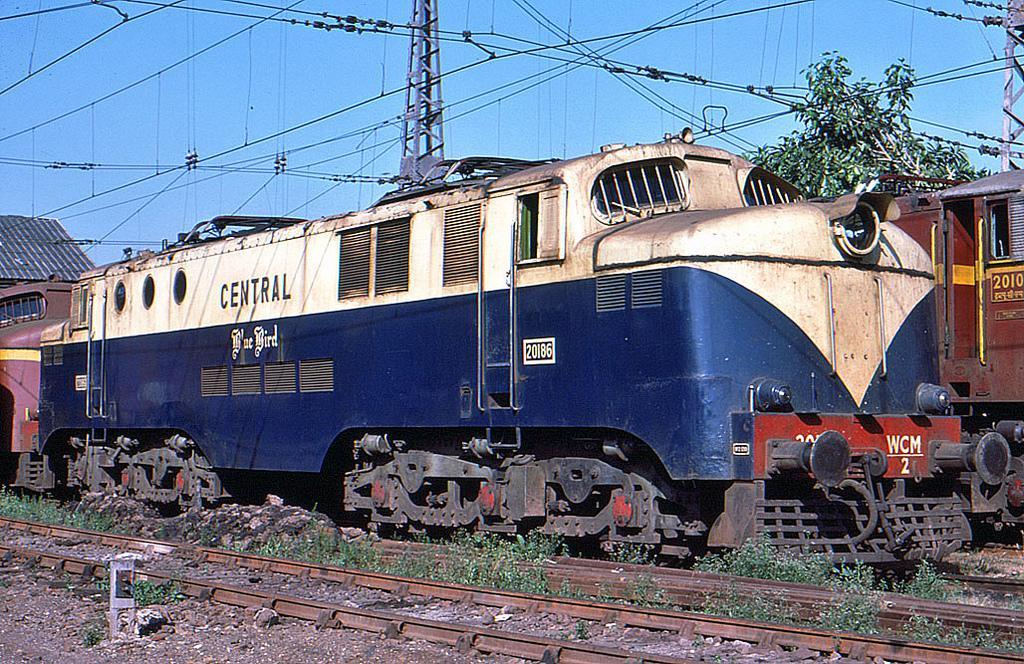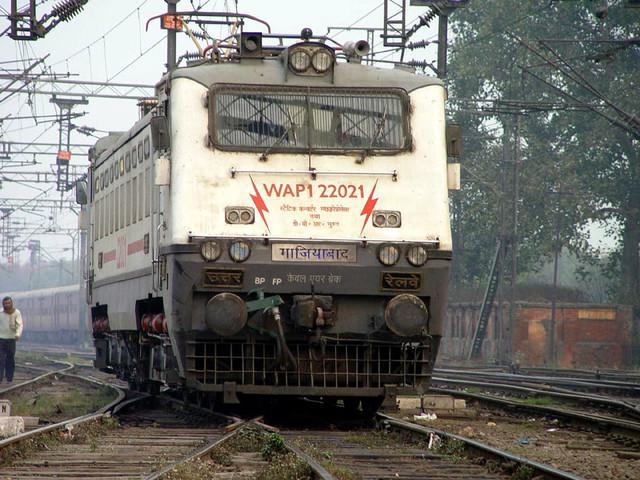The first image is the image on the left, the second image is the image on the right. Given the left and right images, does the statement "One train has a blue body and a white top that extends in an upside-down V-shape on the front of the train." hold true? Answer yes or no. Yes. 